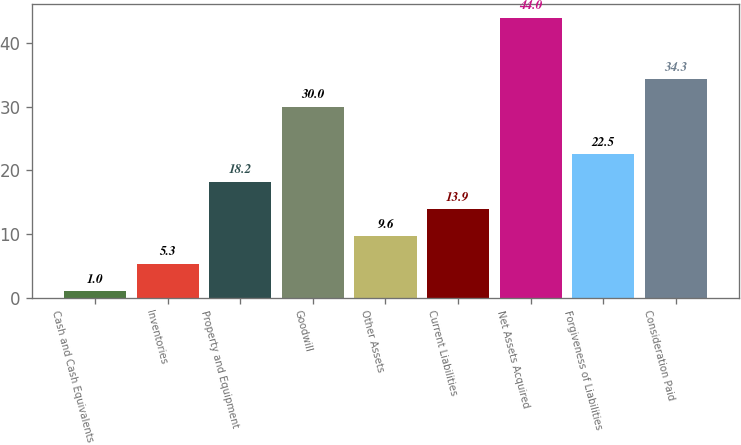<chart> <loc_0><loc_0><loc_500><loc_500><bar_chart><fcel>Cash and Cash Equivalents<fcel>Inventories<fcel>Property and Equipment<fcel>Goodwill<fcel>Other Assets<fcel>Current Liabilities<fcel>Net Assets Acquired<fcel>Forgiveness of Liabilities<fcel>Consideration Paid<nl><fcel>1<fcel>5.3<fcel>18.2<fcel>30<fcel>9.6<fcel>13.9<fcel>44<fcel>22.5<fcel>34.3<nl></chart> 